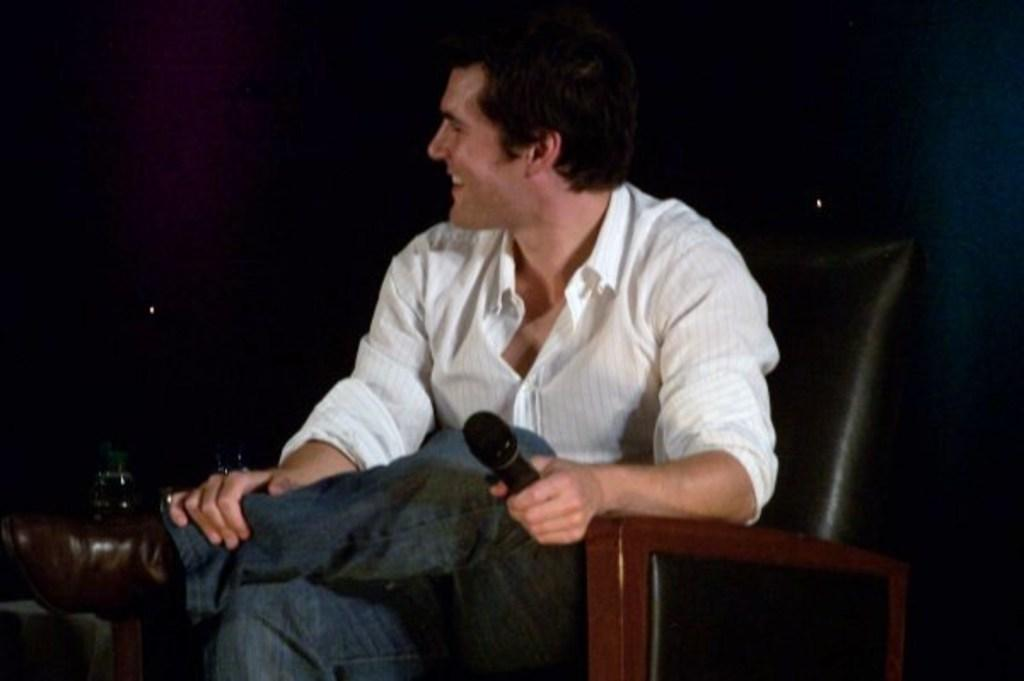What is the main subject of the image? There is a person in the image. What is the person doing in the image? The person is sitting on a chair and holding a microphone. What is the person's facial expression in the image? The person is smiling. How would you describe the background of the image? The background of the image is dark. What type of underwear is the person wearing in the image? There is no information about the person's underwear in the image, so we cannot determine what type they are wearing. 